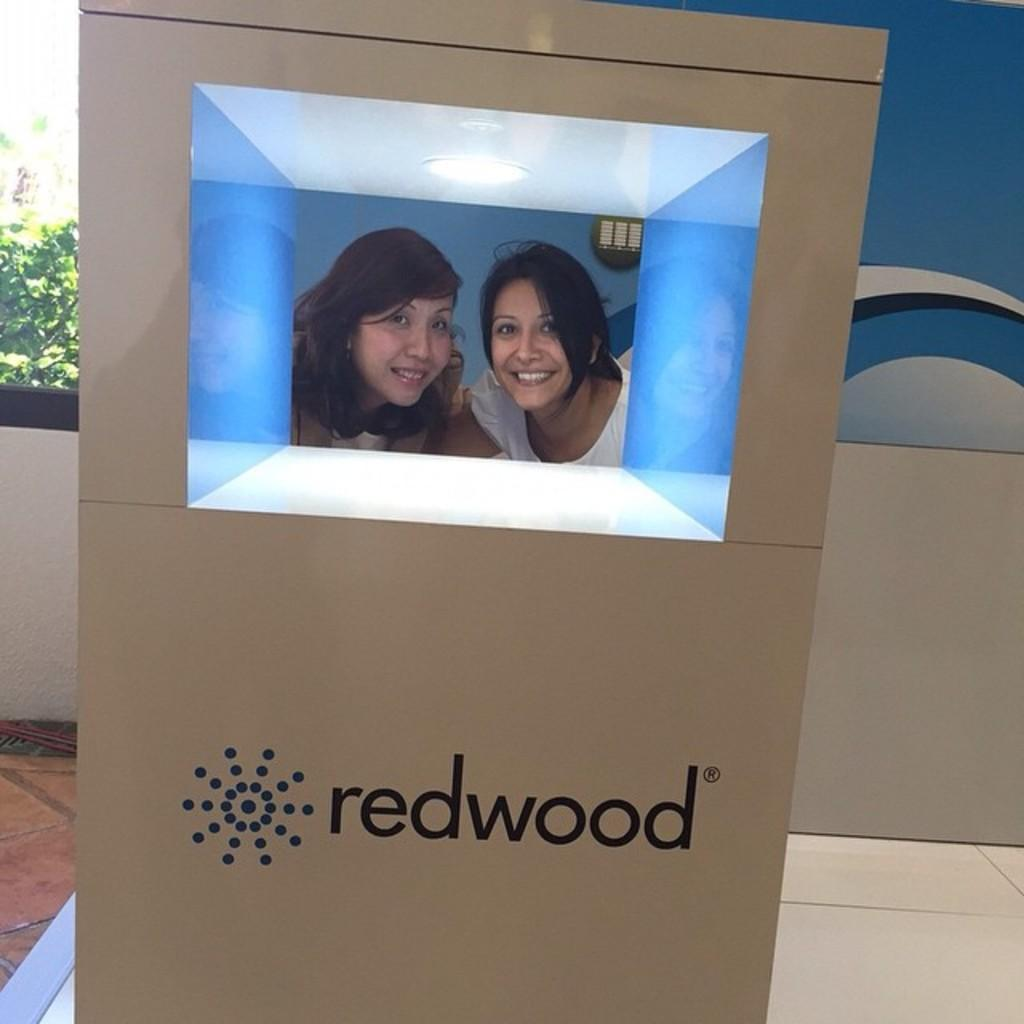What object is present in the image that has a hole in it? There is a box in the image with a hole in it. What can be seen through the hole in the box? Two ladies are visible through the hole in the box. What is written on the box? Something is written on the box. What is visible in the background of the image? There is a wall in the background of the image. What type of vegetation is present on the left side of the image? Leaves are present on the left side of the image. How many trees are visible through the hole in the box? There are no trees visible through the hole in the box; only two ladies are visible. What type of match is being used by the ladies in the image? There is no match present in the image, and the ladies are not using any matches. 